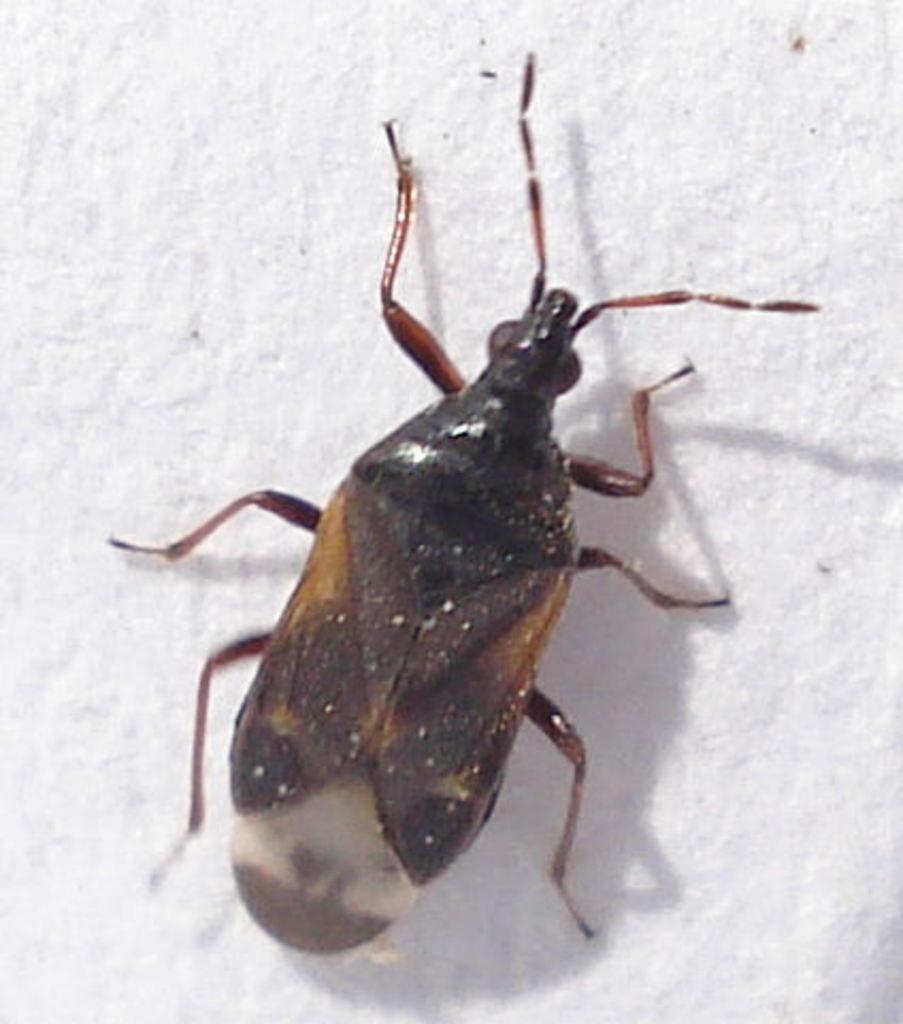In one or two sentences, can you explain what this image depicts? In this picture we can see an insect in the front, it looks like a wall in the background. 